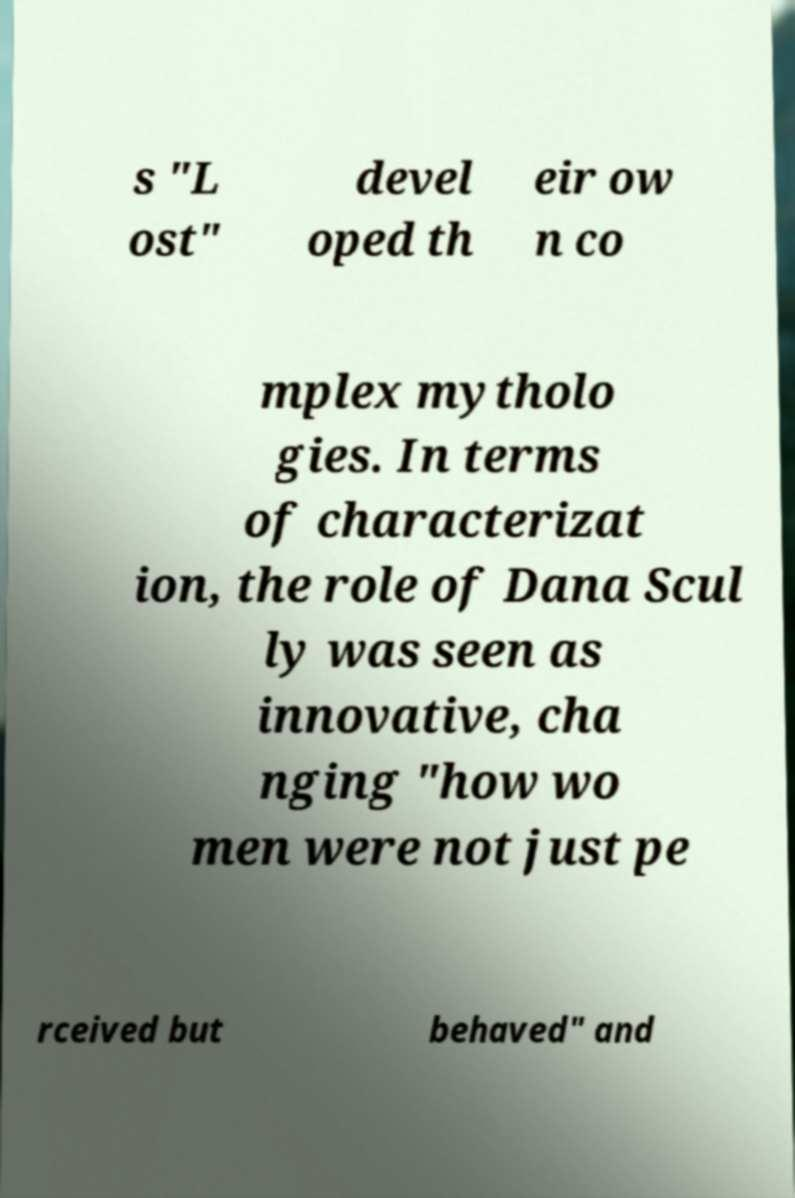Can you accurately transcribe the text from the provided image for me? s "L ost" devel oped th eir ow n co mplex mytholo gies. In terms of characterizat ion, the role of Dana Scul ly was seen as innovative, cha nging "how wo men were not just pe rceived but behaved" and 